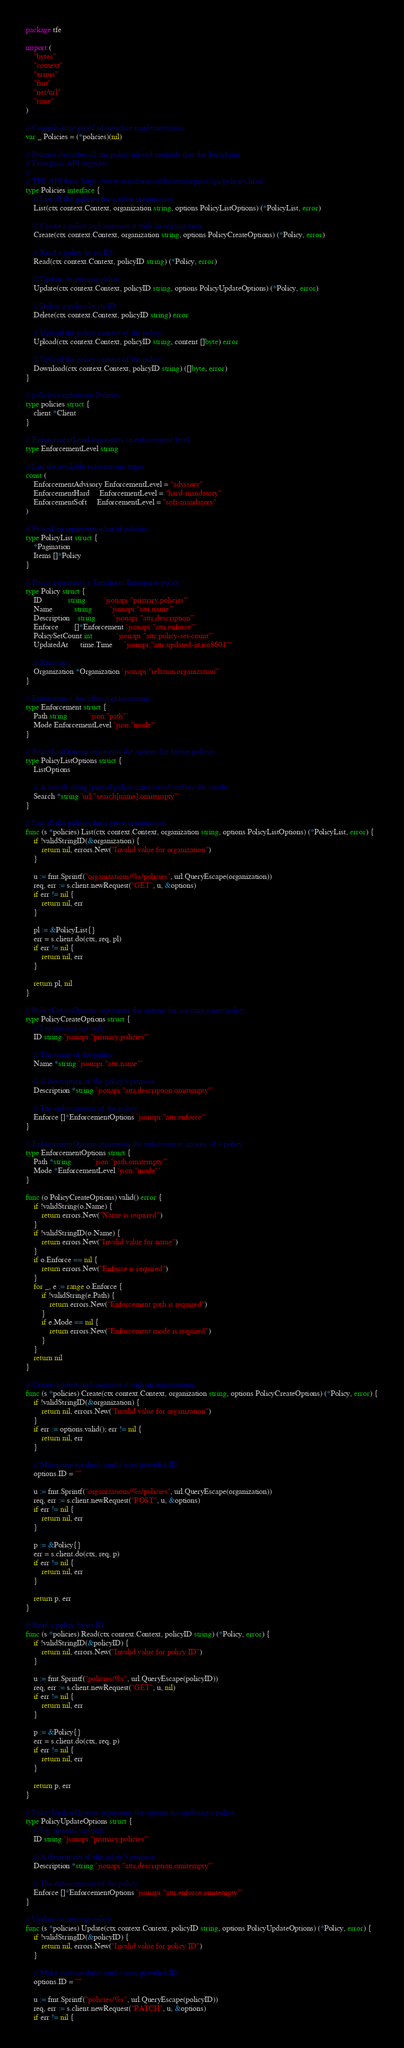Convert code to text. <code><loc_0><loc_0><loc_500><loc_500><_Go_>package tfe

import (
	"bytes"
	"context"
	"errors"
	"fmt"
	"net/url"
	"time"
)

// Compile-time proof of interface implementation.
var _ Policies = (*policies)(nil)

// Policies describes all the policy related methods that the Terraform
// Enterprise API supports.
//
// TFE API docs: https://www.terraform.io/docs/enterprise/api/policies.html
type Policies interface {
	// List all the policies for a given organization
	List(ctx context.Context, organization string, options PolicyListOptions) (*PolicyList, error)

	// Create a policy and associate it with an organization.
	Create(ctx context.Context, organization string, options PolicyCreateOptions) (*Policy, error)

	// Read a policy by its ID.
	Read(ctx context.Context, policyID string) (*Policy, error)

	// Update an existing policy.
	Update(ctx context.Context, policyID string, options PolicyUpdateOptions) (*Policy, error)

	// Delete a policy by its ID.
	Delete(ctx context.Context, policyID string) error

	// Upload the policy content of the policy.
	Upload(ctx context.Context, policyID string, content []byte) error

	// Upload the policy content of the policy.
	Download(ctx context.Context, policyID string) ([]byte, error)
}

// policies implements Policies.
type policies struct {
	client *Client
}

// EnforcementLevel represents an enforcement level.
type EnforcementLevel string

// List the available enforcement types.
const (
	EnforcementAdvisory EnforcementLevel = "advisory"
	EnforcementHard     EnforcementLevel = "hard-mandatory"
	EnforcementSoft     EnforcementLevel = "soft-mandatory"
)

// PolicyList represents a list of policies..
type PolicyList struct {
	*Pagination
	Items []*Policy
}

// Policy represents a Terraform Enterprise policy.
type Policy struct {
	ID             string         `jsonapi:"primary,policies"`
	Name           string         `jsonapi:"attr,name"`
	Description    string         `jsonapi:"attr,description"`
	Enforce        []*Enforcement `jsonapi:"attr,enforce"`
	PolicySetCount int            `jsonapi:"attr,policy-set-count"`
	UpdatedAt      time.Time      `jsonapi:"attr,updated-at,iso8601"`

	// Relations
	Organization *Organization `jsonapi:"relation,organization"`
}

// Enforcement describes a enforcement.
type Enforcement struct {
	Path string           `json:"path"`
	Mode EnforcementLevel `json:"mode"`
}

// PolicyListOptions represents the options for listing policies.
type PolicyListOptions struct {
	ListOptions

	// A search string (partial policy name) used to filter the results.
	Search *string `url:"search[name],omitempty"`
}

// List all the policies for a given organization
func (s *policies) List(ctx context.Context, organization string, options PolicyListOptions) (*PolicyList, error) {
	if !validStringID(&organization) {
		return nil, errors.New("Invalid value for organization")
	}

	u := fmt.Sprintf("organizations/%s/policies", url.QueryEscape(organization))
	req, err := s.client.newRequest("GET", u, &options)
	if err != nil {
		return nil, err
	}

	pl := &PolicyList{}
	err = s.client.do(ctx, req, pl)
	if err != nil {
		return nil, err
	}

	return pl, nil
}

// PolicyCreateOptions represents the options for creating a new policy.
type PolicyCreateOptions struct {
	// For internal use only!
	ID string `jsonapi:"primary,policies"`

	// The name of the policy.
	Name *string `jsonapi:"attr,name"`

	// A description of the policy's purpose.
	Description *string `jsonapi:"attr,description,omitempty"`

	// The enforcements of the policy.
	Enforce []*EnforcementOptions `jsonapi:"attr,enforce"`
}

// EnforcementOptions represents the enforcement options of a policy.
type EnforcementOptions struct {
	Path *string           `json:"path,omitempty"`
	Mode *EnforcementLevel `json:"mode"`
}

func (o PolicyCreateOptions) valid() error {
	if !validString(o.Name) {
		return errors.New("Name is required")
	}
	if !validStringID(o.Name) {
		return errors.New("Invalid value for name")
	}
	if o.Enforce == nil {
		return errors.New("Enforce is required")
	}
	for _, e := range o.Enforce {
		if !validString(e.Path) {
			return errors.New("Enforcement path is required")
		}
		if e.Mode == nil {
			return errors.New("Enforcement mode is required")
		}
	}
	return nil
}

// Create a policy and associate it with an organization.
func (s *policies) Create(ctx context.Context, organization string, options PolicyCreateOptions) (*Policy, error) {
	if !validStringID(&organization) {
		return nil, errors.New("Invalid value for organization")
	}
	if err := options.valid(); err != nil {
		return nil, err
	}

	// Make sure we don't send a user provided ID.
	options.ID = ""

	u := fmt.Sprintf("organizations/%s/policies", url.QueryEscape(organization))
	req, err := s.client.newRequest("POST", u, &options)
	if err != nil {
		return nil, err
	}

	p := &Policy{}
	err = s.client.do(ctx, req, p)
	if err != nil {
		return nil, err
	}

	return p, err
}

// Read a policy by its ID.
func (s *policies) Read(ctx context.Context, policyID string) (*Policy, error) {
	if !validStringID(&policyID) {
		return nil, errors.New("Invalid value for policy ID")
	}

	u := fmt.Sprintf("policies/%s", url.QueryEscape(policyID))
	req, err := s.client.newRequest("GET", u, nil)
	if err != nil {
		return nil, err
	}

	p := &Policy{}
	err = s.client.do(ctx, req, p)
	if err != nil {
		return nil, err
	}

	return p, err
}

// PolicyUpdateOptions represents the options for updating a policy.
type PolicyUpdateOptions struct {
	// For internal use only!
	ID string `jsonapi:"primary,policies"`

	// A description of the policy's purpose.
	Description *string `jsonapi:"attr,description,omitempty"`

	// The enforcements of the policy.
	Enforce []*EnforcementOptions `jsonapi:"attr,enforce,omitempty"`
}

// Update an existing policy.
func (s *policies) Update(ctx context.Context, policyID string, options PolicyUpdateOptions) (*Policy, error) {
	if !validStringID(&policyID) {
		return nil, errors.New("Invalid value for policy ID")
	}

	// Make sure we don't send a user provided ID.
	options.ID = ""

	u := fmt.Sprintf("policies/%s", url.QueryEscape(policyID))
	req, err := s.client.newRequest("PATCH", u, &options)
	if err != nil {</code> 